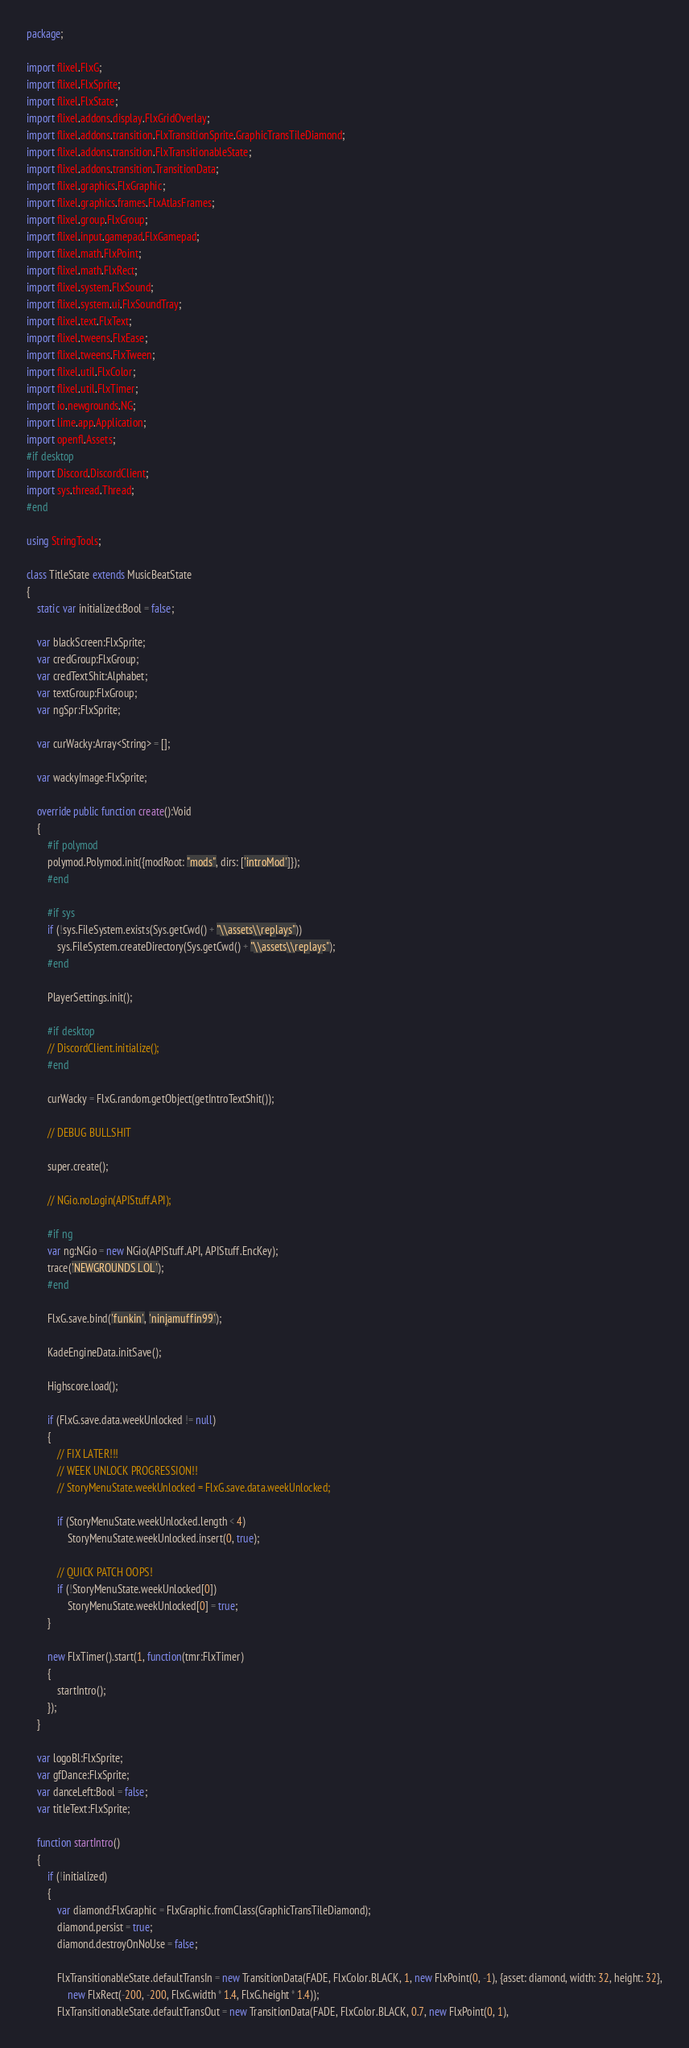Convert code to text. <code><loc_0><loc_0><loc_500><loc_500><_Haxe_>package;

import flixel.FlxG;
import flixel.FlxSprite;
import flixel.FlxState;
import flixel.addons.display.FlxGridOverlay;
import flixel.addons.transition.FlxTransitionSprite.GraphicTransTileDiamond;
import flixel.addons.transition.FlxTransitionableState;
import flixel.addons.transition.TransitionData;
import flixel.graphics.FlxGraphic;
import flixel.graphics.frames.FlxAtlasFrames;
import flixel.group.FlxGroup;
import flixel.input.gamepad.FlxGamepad;
import flixel.math.FlxPoint;
import flixel.math.FlxRect;
import flixel.system.FlxSound;
import flixel.system.ui.FlxSoundTray;
import flixel.text.FlxText;
import flixel.tweens.FlxEase;
import flixel.tweens.FlxTween;
import flixel.util.FlxColor;
import flixel.util.FlxTimer;
import io.newgrounds.NG;
import lime.app.Application;
import openfl.Assets;
#if desktop
import Discord.DiscordClient;
import sys.thread.Thread;
#end

using StringTools;

class TitleState extends MusicBeatState
{
	static var initialized:Bool = false;

	var blackScreen:FlxSprite;
	var credGroup:FlxGroup;
	var credTextShit:Alphabet;
	var textGroup:FlxGroup;
	var ngSpr:FlxSprite;

	var curWacky:Array<String> = [];

	var wackyImage:FlxSprite;

	override public function create():Void
	{
		#if polymod
		polymod.Polymod.init({modRoot: "mods", dirs: ['introMod']});
		#end

		#if sys
		if (!sys.FileSystem.exists(Sys.getCwd() + "\\assets\\replays"))
			sys.FileSystem.createDirectory(Sys.getCwd() + "\\assets\\replays");
		#end

		PlayerSettings.init();

		#if desktop
		// DiscordClient.initialize();
		#end

		curWacky = FlxG.random.getObject(getIntroTextShit());

		// DEBUG BULLSHIT

		super.create();

		// NGio.noLogin(APIStuff.API);

		#if ng
		var ng:NGio = new NGio(APIStuff.API, APIStuff.EncKey);
		trace('NEWGROUNDS LOL');
		#end

		FlxG.save.bind('funkin', 'ninjamuffin99');

		KadeEngineData.initSave();

		Highscore.load();

		if (FlxG.save.data.weekUnlocked != null)
		{
			// FIX LATER!!!
			// WEEK UNLOCK PROGRESSION!!
			// StoryMenuState.weekUnlocked = FlxG.save.data.weekUnlocked;

			if (StoryMenuState.weekUnlocked.length < 4)
				StoryMenuState.weekUnlocked.insert(0, true);

			// QUICK PATCH OOPS!
			if (!StoryMenuState.weekUnlocked[0])
				StoryMenuState.weekUnlocked[0] = true;
		}

		new FlxTimer().start(1, function(tmr:FlxTimer)
		{
			startIntro();
		});
	}

	var logoBl:FlxSprite;
	var gfDance:FlxSprite;
	var danceLeft:Bool = false;
	var titleText:FlxSprite;

	function startIntro()
	{
		if (!initialized)
		{
			var diamond:FlxGraphic = FlxGraphic.fromClass(GraphicTransTileDiamond);
			diamond.persist = true;
			diamond.destroyOnNoUse = false;

			FlxTransitionableState.defaultTransIn = new TransitionData(FADE, FlxColor.BLACK, 1, new FlxPoint(0, -1), {asset: diamond, width: 32, height: 32},
				new FlxRect(-200, -200, FlxG.width * 1.4, FlxG.height * 1.4));
			FlxTransitionableState.defaultTransOut = new TransitionData(FADE, FlxColor.BLACK, 0.7, new FlxPoint(0, 1),</code> 